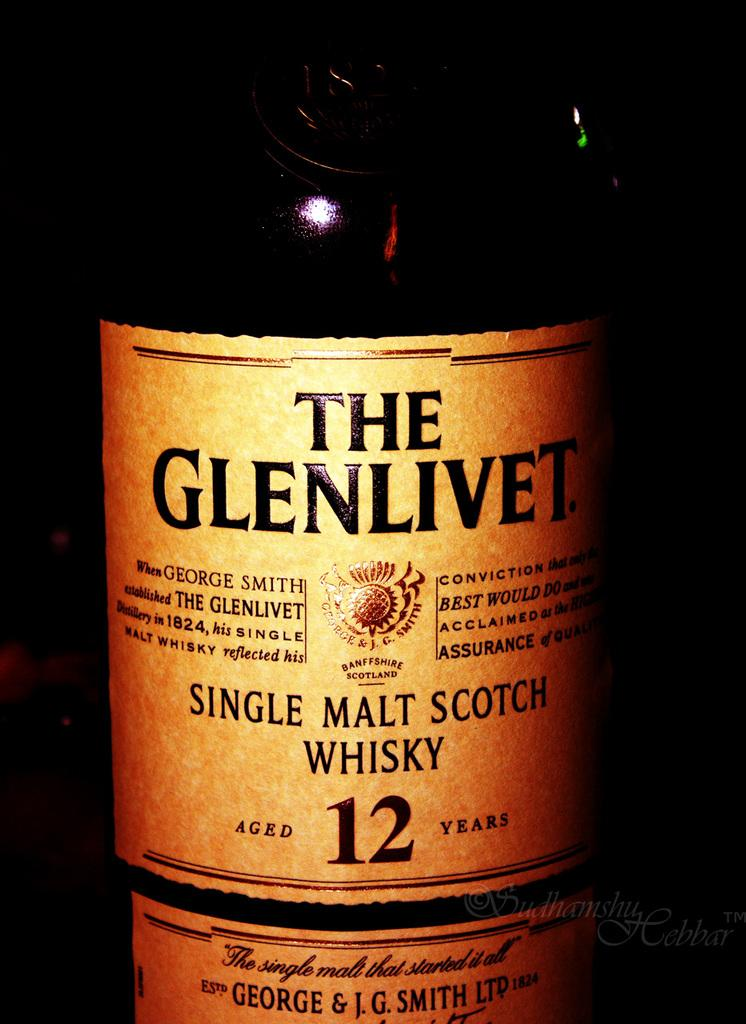Provide a one-sentence caption for the provided image. A bottle of The Glenlivet says on the label that it was aged 12 years. 